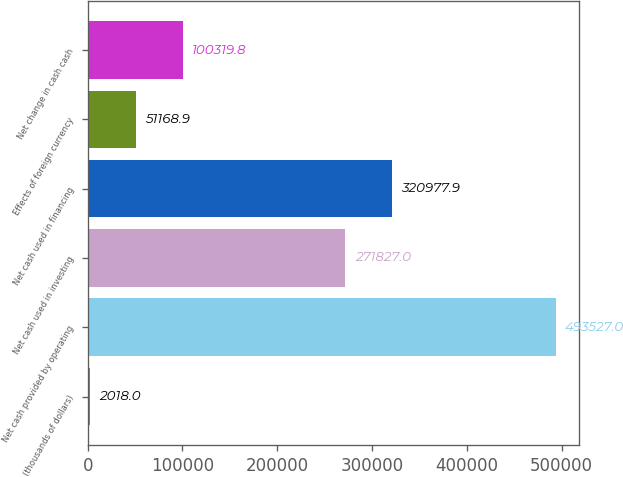Convert chart. <chart><loc_0><loc_0><loc_500><loc_500><bar_chart><fcel>(thousands of dollars)<fcel>Net cash provided by operating<fcel>Net cash used in investing<fcel>Net cash used in financing<fcel>Effects of foreign currency<fcel>Net change in cash cash<nl><fcel>2018<fcel>493527<fcel>271827<fcel>320978<fcel>51168.9<fcel>100320<nl></chart> 